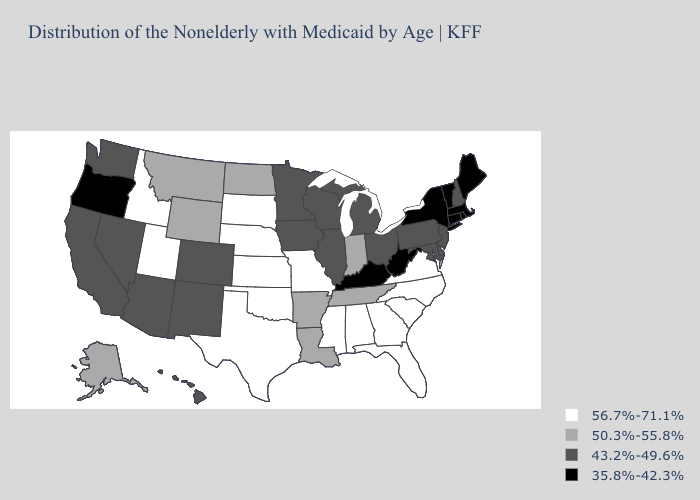What is the value of North Dakota?
Quick response, please. 50.3%-55.8%. Does Pennsylvania have the lowest value in the USA?
Give a very brief answer. No. Does the map have missing data?
Write a very short answer. No. Among the states that border California , does Oregon have the highest value?
Short answer required. No. Name the states that have a value in the range 56.7%-71.1%?
Quick response, please. Alabama, Florida, Georgia, Idaho, Kansas, Mississippi, Missouri, Nebraska, North Carolina, Oklahoma, South Carolina, South Dakota, Texas, Utah, Virginia. What is the value of California?
Write a very short answer. 43.2%-49.6%. Name the states that have a value in the range 50.3%-55.8%?
Give a very brief answer. Alaska, Arkansas, Indiana, Louisiana, Montana, North Dakota, Tennessee, Wyoming. What is the value of Nevada?
Short answer required. 43.2%-49.6%. How many symbols are there in the legend?
Quick response, please. 4. What is the value of Connecticut?
Be succinct. 35.8%-42.3%. Among the states that border North Carolina , which have the highest value?
Answer briefly. Georgia, South Carolina, Virginia. Does Maryland have the highest value in the USA?
Concise answer only. No. Is the legend a continuous bar?
Quick response, please. No. What is the value of Rhode Island?
Answer briefly. 35.8%-42.3%. What is the value of Arkansas?
Answer briefly. 50.3%-55.8%. 